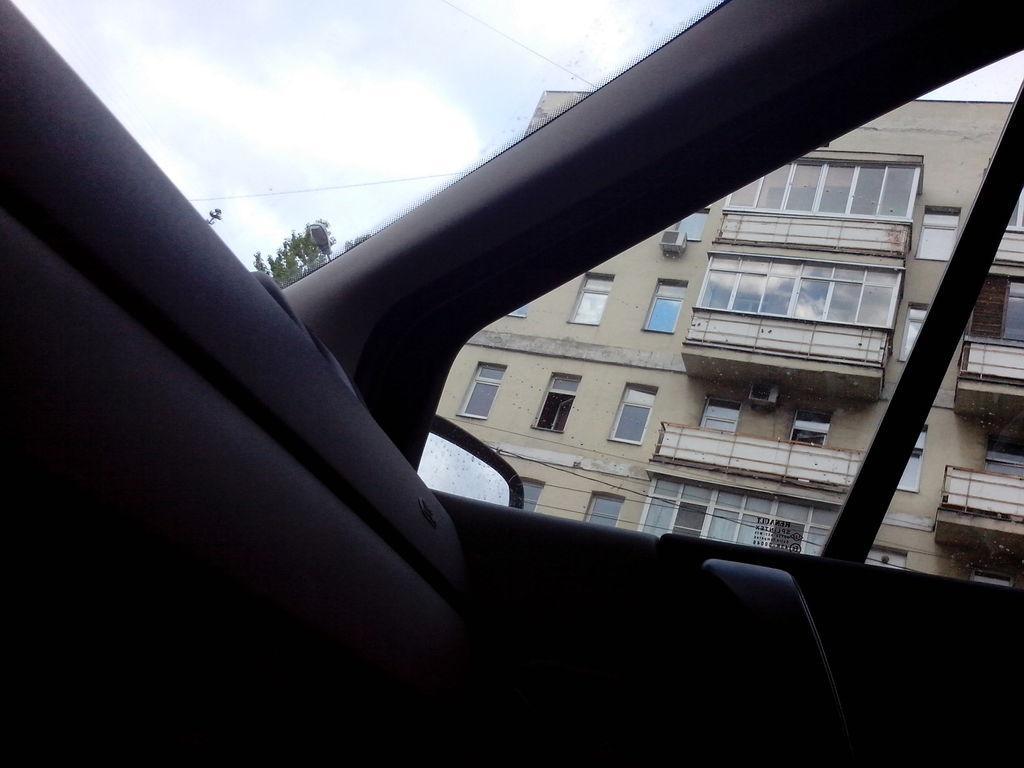Could you give a brief overview of what you see in this image? This image is taken in a car. In the middle of the image there is a car. There is a windshield and there is a window and there is a side mirror. Through the windshield we can see there is a sky with clouds and there is a tree. Through the window we can see there is a building with walls, windows and a roof. 